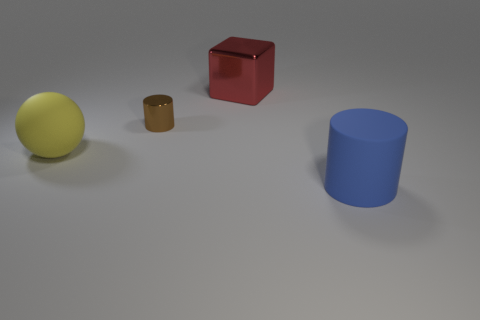Add 1 red metal cylinders. How many objects exist? 5 Subtract all balls. How many objects are left? 3 Add 4 yellow rubber spheres. How many yellow rubber spheres are left? 5 Add 3 small yellow rubber balls. How many small yellow rubber balls exist? 3 Subtract 0 blue spheres. How many objects are left? 4 Subtract all large blue objects. Subtract all matte cylinders. How many objects are left? 2 